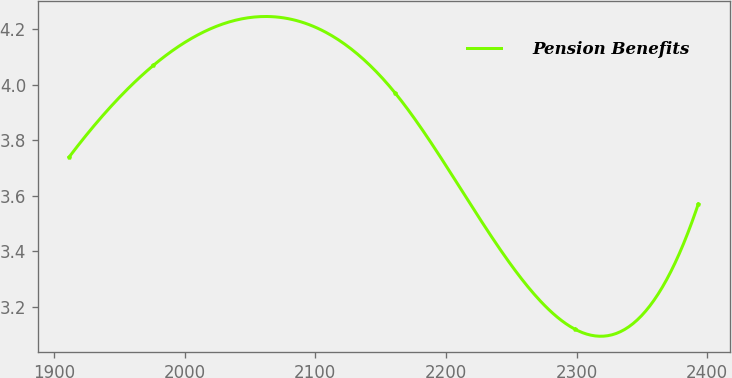Convert chart. <chart><loc_0><loc_0><loc_500><loc_500><line_chart><ecel><fcel>Pension Benefits<nl><fcel>1911.52<fcel>3.74<nl><fcel>1976<fcel>4.07<nl><fcel>2161.17<fcel>3.97<nl><fcel>2298.62<fcel>3.12<nl><fcel>2393.15<fcel>3.57<nl></chart> 